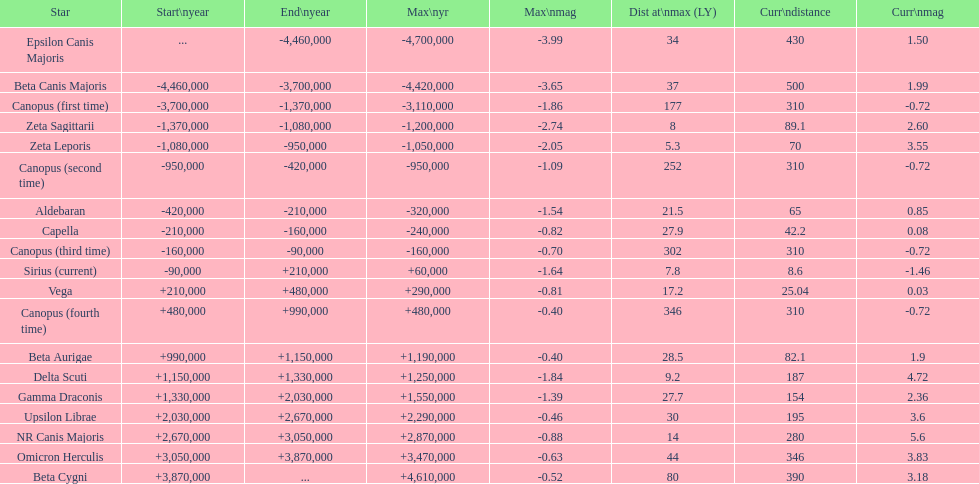How many stars do not have a current magnitude greater than zero? 5. Write the full table. {'header': ['Star', 'Start\\nyear', 'End\\nyear', 'Max\\nyr', 'Max\\nmag', 'Dist at\\nmax (LY)', 'Curr\\ndistance', 'Curr\\nmag'], 'rows': [['Epsilon Canis Majoris', '...', '-4,460,000', '-4,700,000', '-3.99', '34', '430', '1.50'], ['Beta Canis Majoris', '-4,460,000', '-3,700,000', '-4,420,000', '-3.65', '37', '500', '1.99'], ['Canopus (first time)', '-3,700,000', '-1,370,000', '-3,110,000', '-1.86', '177', '310', '-0.72'], ['Zeta Sagittarii', '-1,370,000', '-1,080,000', '-1,200,000', '-2.74', '8', '89.1', '2.60'], ['Zeta Leporis', '-1,080,000', '-950,000', '-1,050,000', '-2.05', '5.3', '70', '3.55'], ['Canopus (second time)', '-950,000', '-420,000', '-950,000', '-1.09', '252', '310', '-0.72'], ['Aldebaran', '-420,000', '-210,000', '-320,000', '-1.54', '21.5', '65', '0.85'], ['Capella', '-210,000', '-160,000', '-240,000', '-0.82', '27.9', '42.2', '0.08'], ['Canopus (third time)', '-160,000', '-90,000', '-160,000', '-0.70', '302', '310', '-0.72'], ['Sirius (current)', '-90,000', '+210,000', '+60,000', '-1.64', '7.8', '8.6', '-1.46'], ['Vega', '+210,000', '+480,000', '+290,000', '-0.81', '17.2', '25.04', '0.03'], ['Canopus (fourth time)', '+480,000', '+990,000', '+480,000', '-0.40', '346', '310', '-0.72'], ['Beta Aurigae', '+990,000', '+1,150,000', '+1,190,000', '-0.40', '28.5', '82.1', '1.9'], ['Delta Scuti', '+1,150,000', '+1,330,000', '+1,250,000', '-1.84', '9.2', '187', '4.72'], ['Gamma Draconis', '+1,330,000', '+2,030,000', '+1,550,000', '-1.39', '27.7', '154', '2.36'], ['Upsilon Librae', '+2,030,000', '+2,670,000', '+2,290,000', '-0.46', '30', '195', '3.6'], ['NR Canis Majoris', '+2,670,000', '+3,050,000', '+2,870,000', '-0.88', '14', '280', '5.6'], ['Omicron Herculis', '+3,050,000', '+3,870,000', '+3,470,000', '-0.63', '44', '346', '3.83'], ['Beta Cygni', '+3,870,000', '...', '+4,610,000', '-0.52', '80', '390', '3.18']]} 